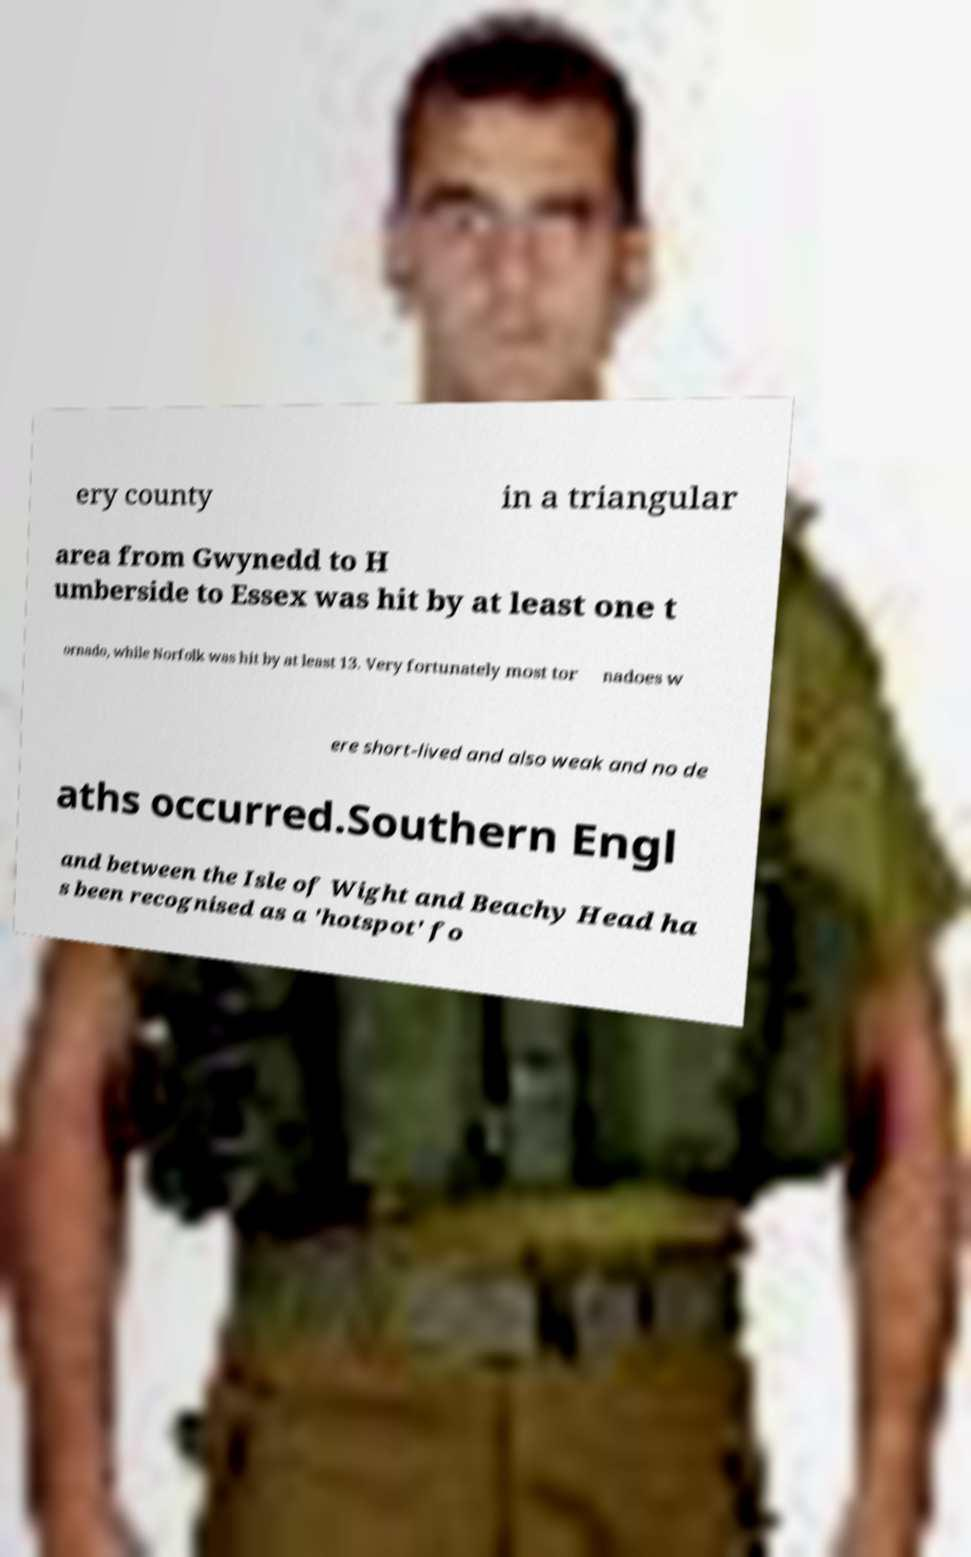I need the written content from this picture converted into text. Can you do that? ery county in a triangular area from Gwynedd to H umberside to Essex was hit by at least one t ornado, while Norfolk was hit by at least 13. Very fortunately most tor nadoes w ere short-lived and also weak and no de aths occurred.Southern Engl and between the Isle of Wight and Beachy Head ha s been recognised as a 'hotspot' fo 